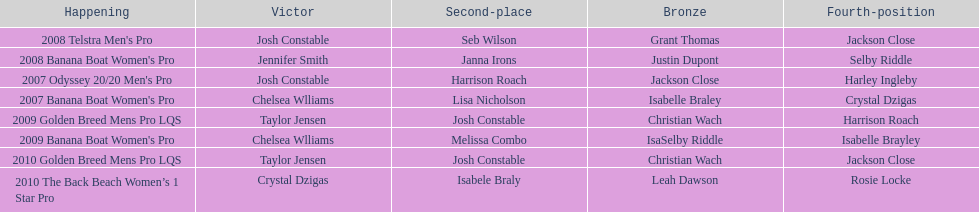Name each of the years that taylor jensen was winner. 2009, 2010. 